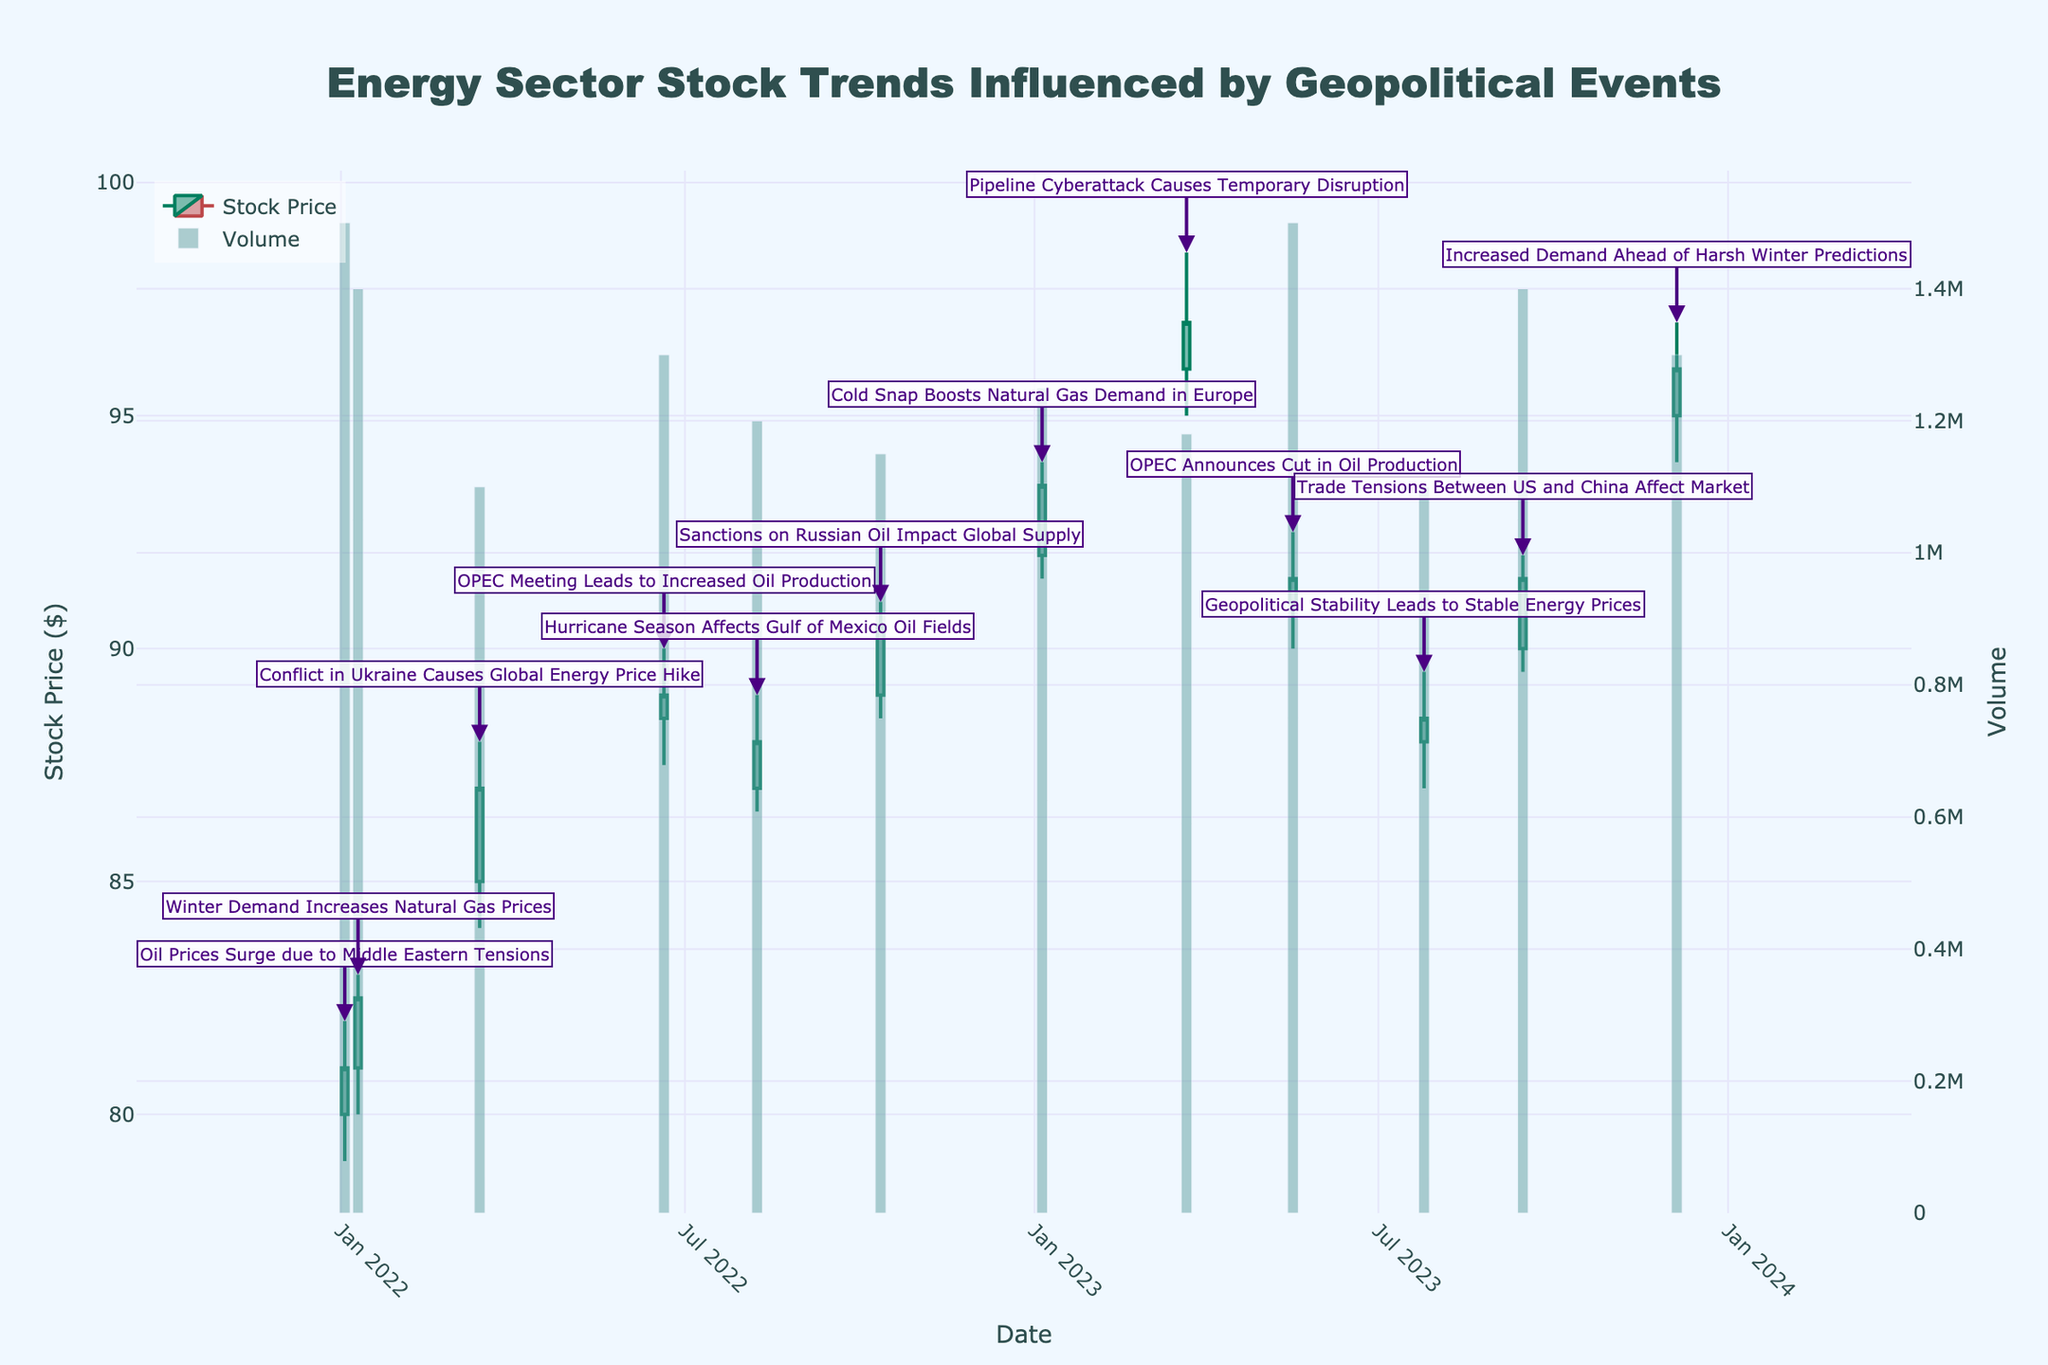which event had the highest stock price close? From the figure, identify the annotation that marks the highest close value on the candlestick chart. Look for the event around that point.
Answer: Pipeline Cyberattack Causes Temporary Disruption when was the stock price the highest during the day? Look for the candlestick with the tallest vertical line. The top of this candlestick indicates the highest stock price during the day. Find the corresponding date and event.
Answer: March 22, 2023 (Pipeline Cyberattack) how did the stock price react to the OPEC Meeting on June 20, 2022? Follow the candlestick for June 20, 2022. Compare the opening and closing prices to determine the day's overall trend after the OPEC Meeting.
Answer: The stock price increased what was the volume of stocks traded during the Winter Demand Increases Natural Gas Prices event? Check the volume bar corresponding to the annotation for Winter Demand Increases Natural Gas Prices. Read the height of the bar on the secondary y-axis (Volume).
Answer: 1,400,000 how did the stock price change from the Cold Snap event to the Pipeline Cyberattack event? Locate the candlestick for the Cold Snap on January 5, 2023, noting its closing price. Similarly, note the closing price for the Pipeline Cyberattack on March 22, 2023. Calculate the difference between these two closing prices.
Answer: Increased by $3.50 which event had the lowest stock price close? Identify the candlestick with the lowest close value across the entire chart. Check the corresponding event annotation for that day.
Answer: OPEC Announces Cut in Oil Production what trend do you observe in stock prices during winter months? Examine the candlestick plots for the months of January and December in each year. Summarize the direction of the price movement.
Answer: Generally upward trend compare the volume of stocks traded during Hurricane Season and Geopolitical Stability events. Which had higher volume? Look at the volume bars corresponding to the Hurricane Season event on August 8, 2022, and the Geopolitical Stability event on July 25, 2023. Compare their heights.
Answer: Hurricane Season 